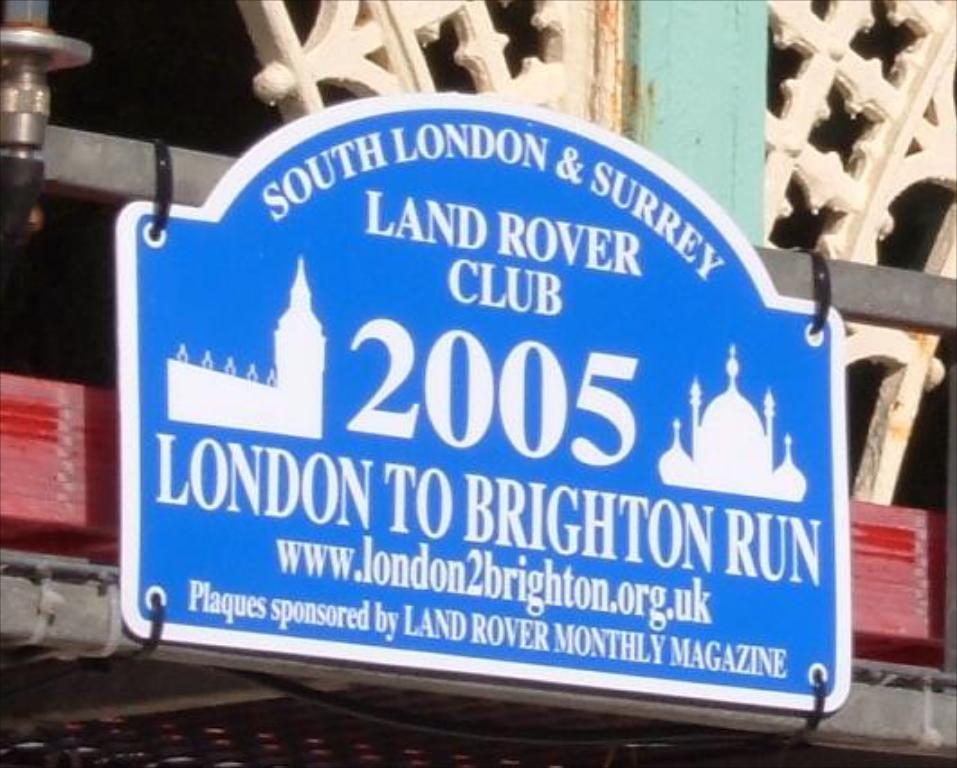What club is this?
Ensure brevity in your answer.  Land rover. Is the london to brighton run a train?
Ensure brevity in your answer.  Unanswerable. 